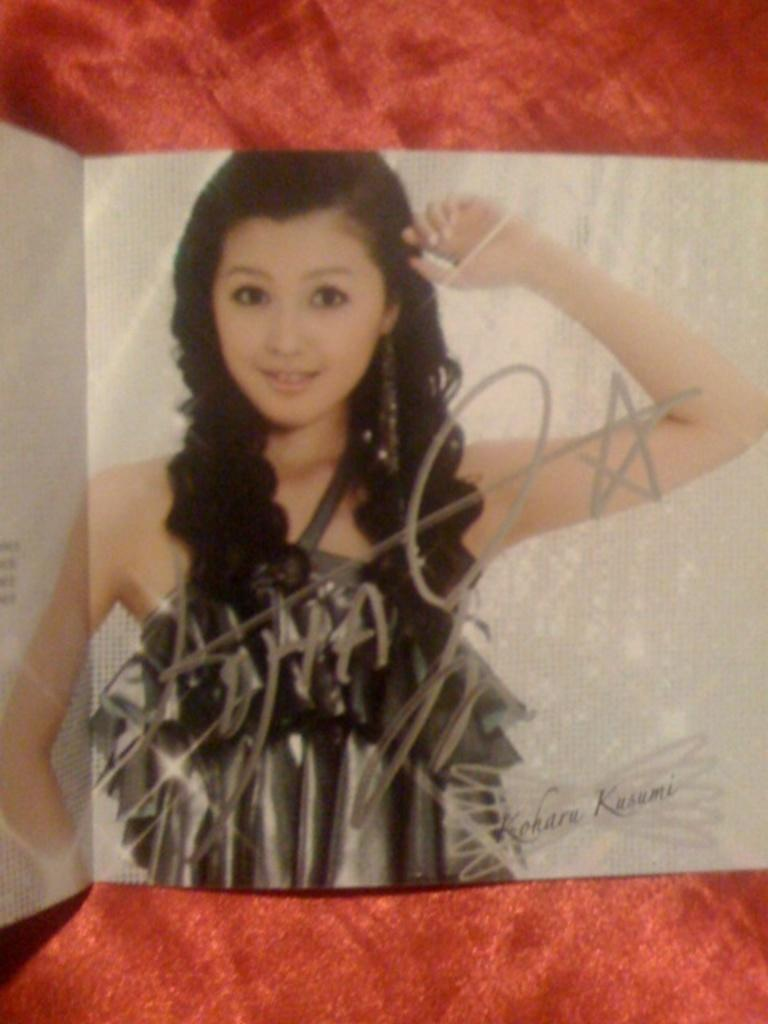What is the main subject of the picture? The main subject of the picture is a woman. What is the woman doing in the picture? The woman is standing and smiling. What is the woman wearing in the picture? The woman is wearing a black dress. What can be seen behind the woman in the picture? There is a white backdrop in the picture. What object can be seen on a red surface in the picture? A book is placed on a red surface. What medical condition does the woman need to be treated for in the hospital? There is no indication in the image that the woman has a medical condition or is in a hospital. 